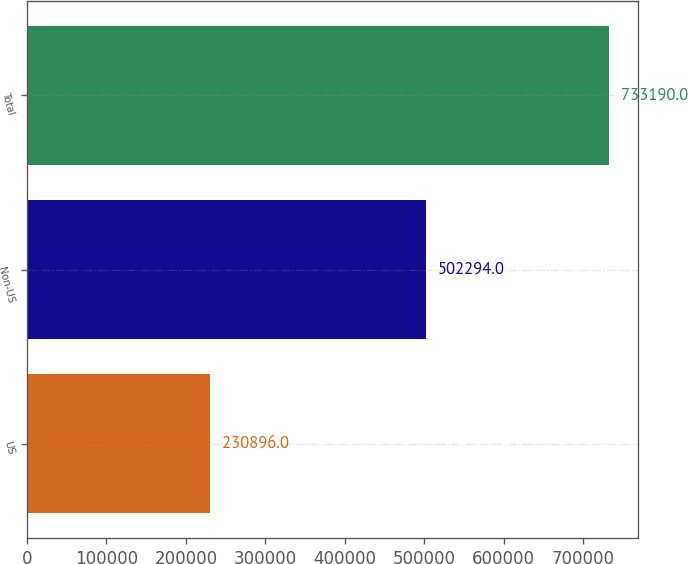Convert chart. <chart><loc_0><loc_0><loc_500><loc_500><bar_chart><fcel>US<fcel>Non-US<fcel>Total<nl><fcel>230896<fcel>502294<fcel>733190<nl></chart> 